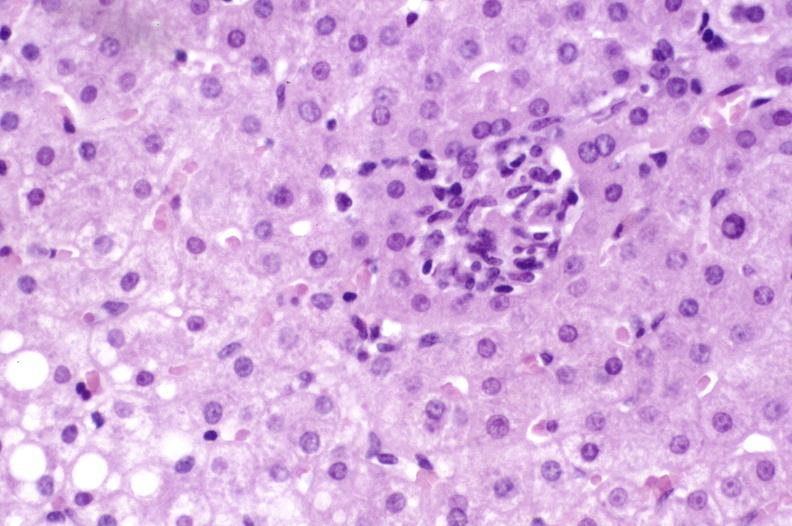what is present?
Answer the question using a single word or phrase. Hepatobiliary 